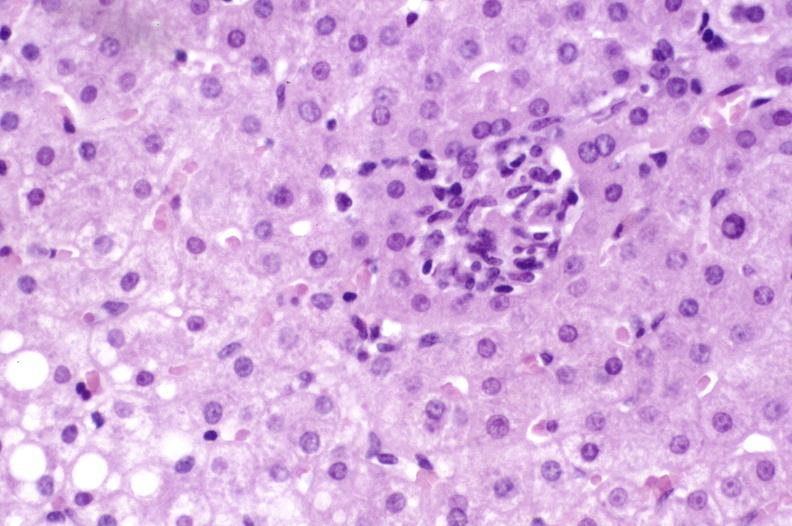what is present?
Answer the question using a single word or phrase. Hepatobiliary 